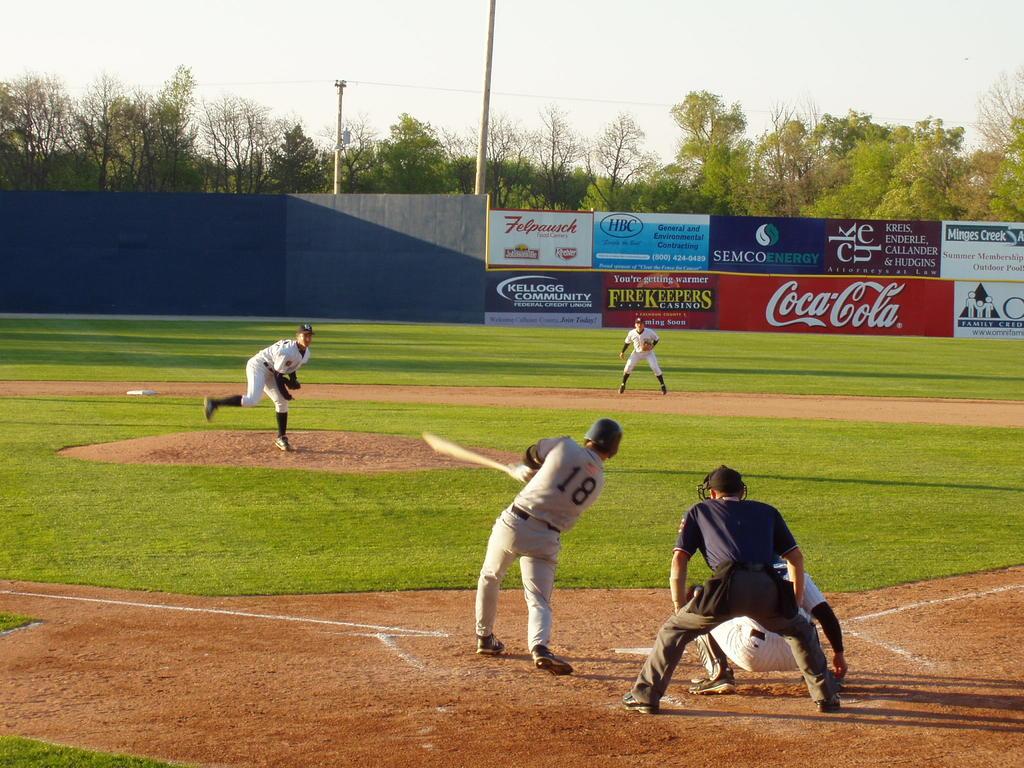What soda is a sponsor of the ball park?
Offer a very short reply. Coca cola. 